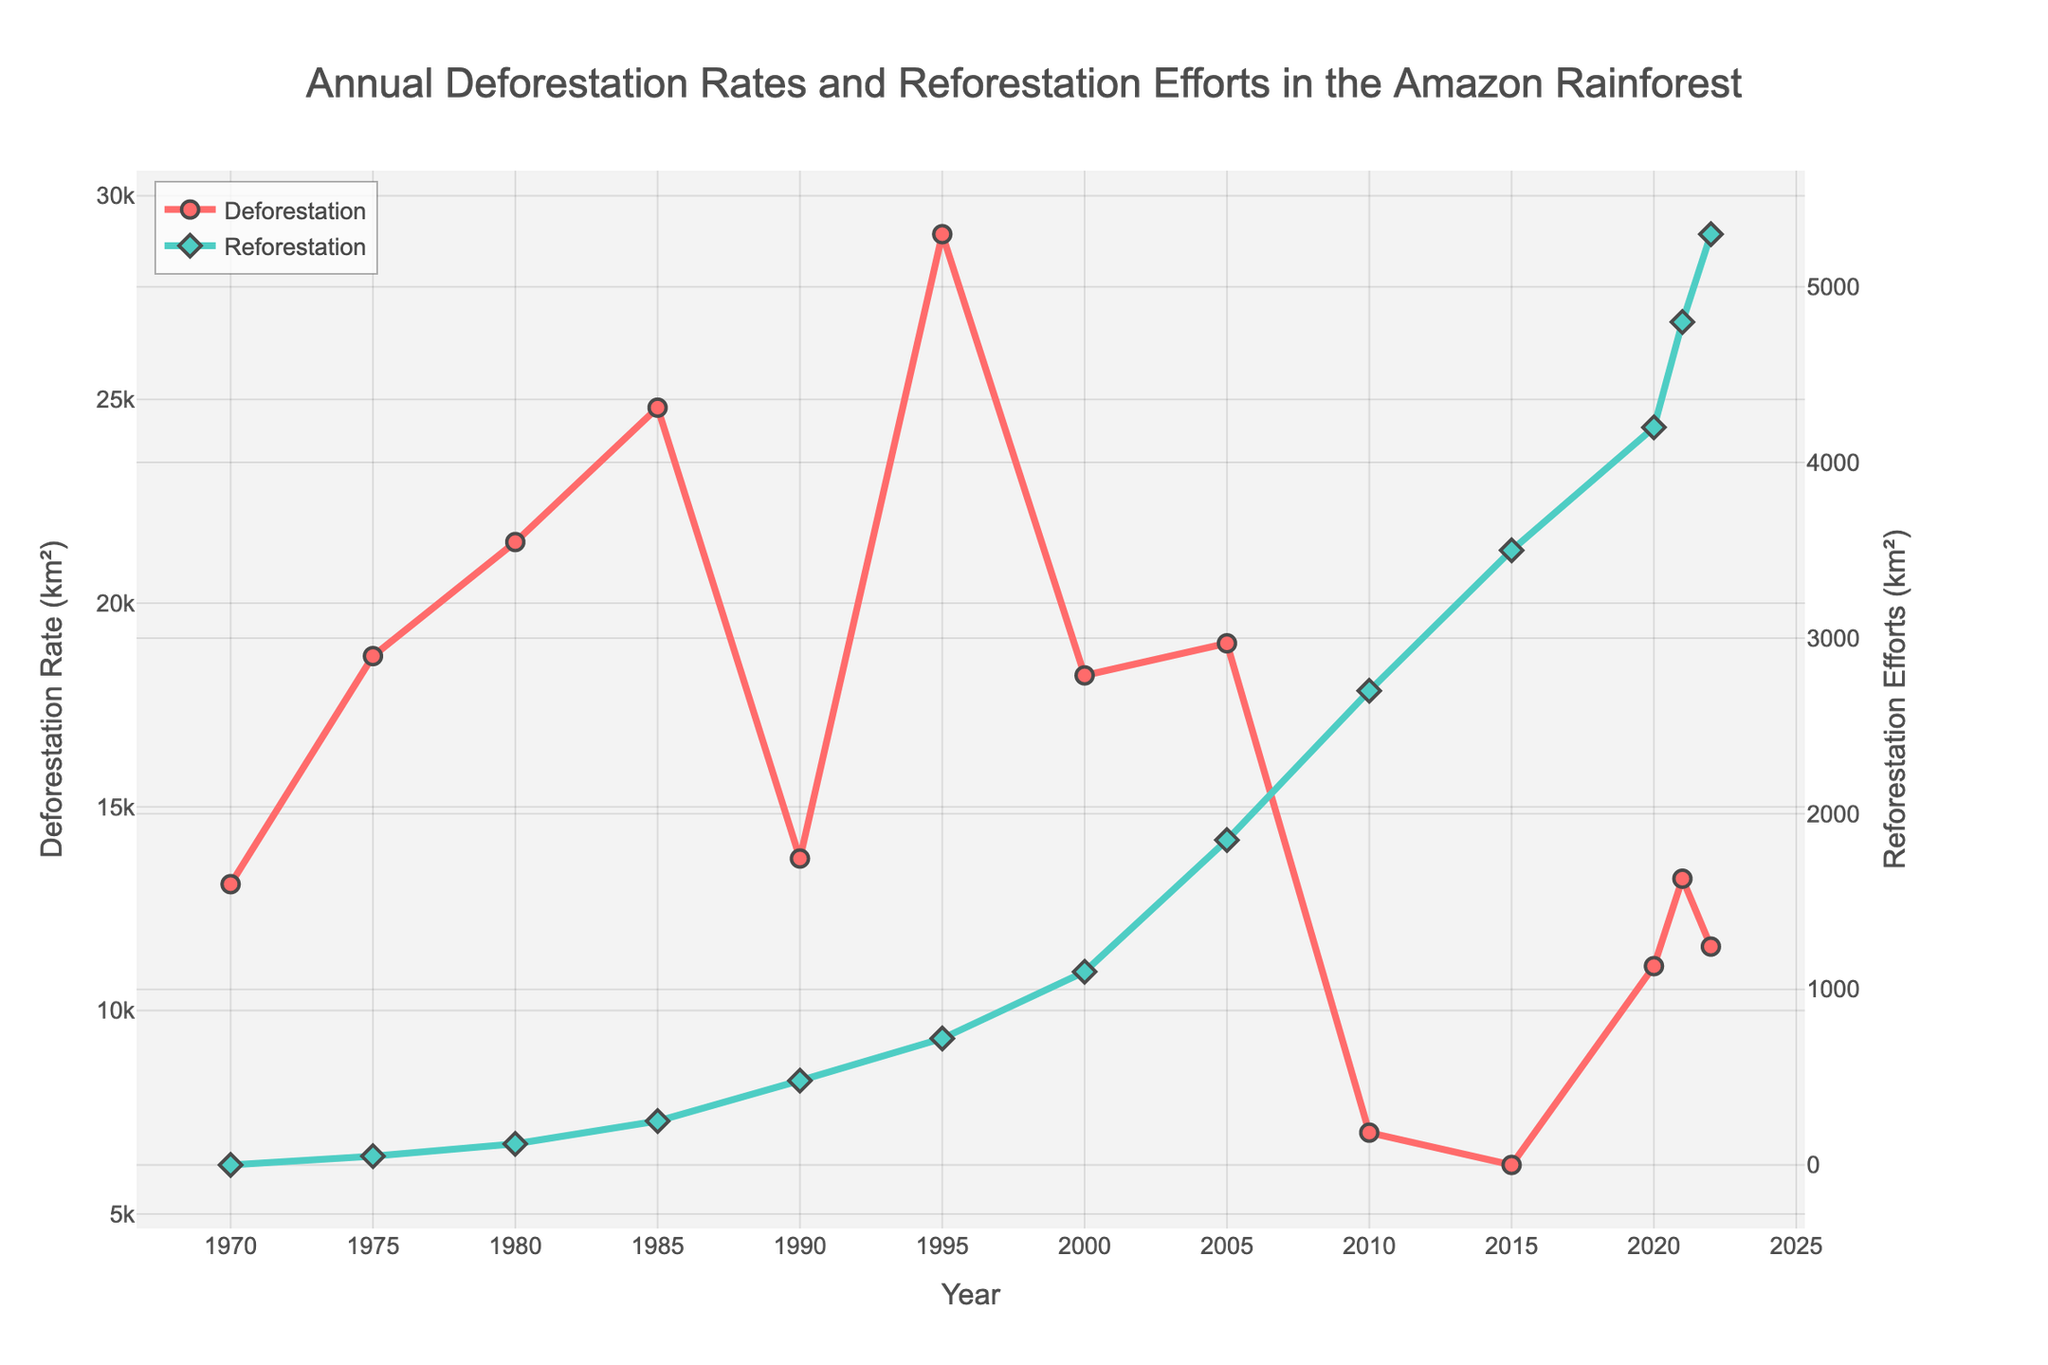What year experienced the highest deforestation rate? The red line representing deforestation rates reaches its peak at the year 1995.
Answer: 1995 Which year had the highest reforestation efforts? The green line representing reforestation efforts reaches its peak at the year 2022.
Answer: 2022 How did the deforestation rate change from 1985 to 1990? From 1985 to 1990, the red line decreases sharply from 24800 km² to 13730 km².
Answer: Decreased What is the difference in deforestation rates between 1970 and 1980? The deforestation rate in 1970 is 13100 km², and in 1980 it is 21500 km². The difference is 21500 - 13100 = 8400 km².
Answer: 8400 km² Which had a greater increase from 1985 to 1995, deforestation or reforestation? The deforestation rate increased from 24800 km² in 1985 to 29059 km² in 1995, an increase of 3259 km². Reforestation efforts increased from 250 km² in 1985 to 720 km² in 1995, an increase of 470 km². Deforestation had a greater increase.
Answer: Deforestation In which year were deforestation rates and reforestation efforts closest in value? The year 2021 shows deforestation at 13235 km² and reforestation at 4800 km². Other years have larger differences between the values; thus, 13235 - 4800 = 8435 km² difference is the closest.
Answer: 2021 What was the trend in reforestation efforts from 2000 to 2022? From 2000 to 2022, the green line representing reforestation efforts shows a steady increasing trend.
Answer: Increasing By how much did reforestation efforts increase from 1990 to 2022? The reforestation efforts in 1990 were 480 km² and in 2022 were 5300 km². The increase is 5300 - 480 = 4820 km².
Answer: 4820 km² What is the average deforestation rate over the period shown? The sum of all deforestation rates from 1970 to 2022 is 226927 km². Dividing by 13 (number of data points), the average is 226927 / 13 ≈ 17448 km².
Answer: 17448 km² 